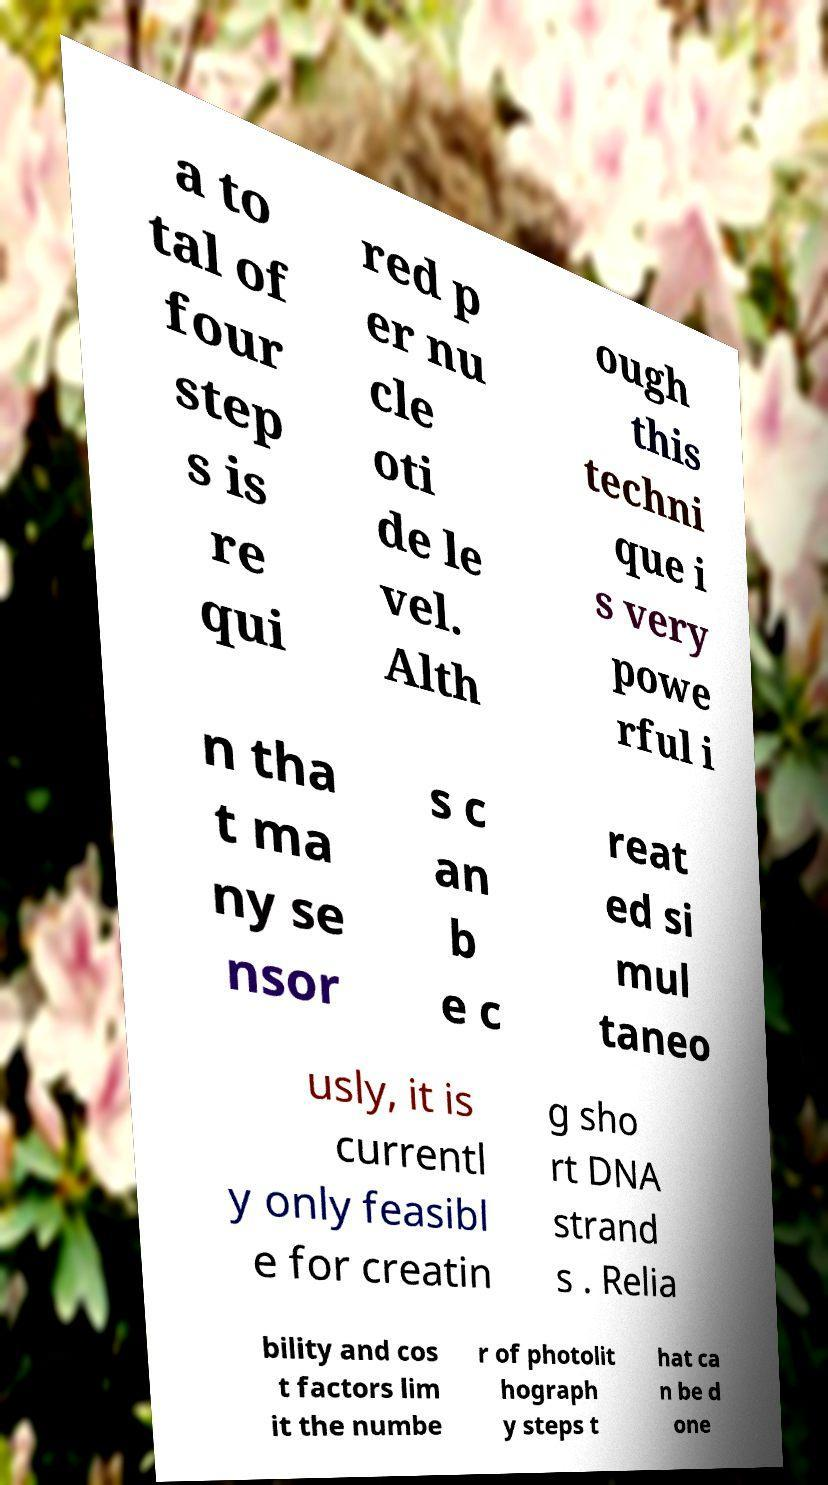Could you assist in decoding the text presented in this image and type it out clearly? a to tal of four step s is re qui red p er nu cle oti de le vel. Alth ough this techni que i s very powe rful i n tha t ma ny se nsor s c an b e c reat ed si mul taneo usly, it is currentl y only feasibl e for creatin g sho rt DNA strand s . Relia bility and cos t factors lim it the numbe r of photolit hograph y steps t hat ca n be d one 